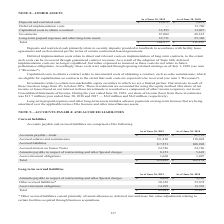According to Opentext Corporation's financial document, What are Deposits and restricted cash primarily related to? security deposits provided to landlords in accordance with facility lease agreements and cash restricted per the terms of certain contractual-based agreements. The document states: "Deposits and restricted cash primarily relate to security deposits provided to landlords in accordance with facility lease agreements and cash restric..." Also, What is the result of the adoption of Topic 606? deferred implementation costs are no longer capitalized, but rather expensed as incurred. The document states: "venues. As a result of the adoption of Topic 606, deferred implementation costs are no longer capitalized, but rather expensed as incurred as these co..." Also, What are the Fiscal years included in the table? The document shows two values: 2019 and 2018. From the document: "As of June 30, 2019 As of June 30, 2018 Deposits and restricted cash $ 13,671 $ 9,479 Deferred implementation costs — 1 As of June 30, 2019 As of June..." Also, can you calculate: What is the percentage difference of Deposits and restricted cash for June 30, 2019 vs June 30, 2018? To answer this question, I need to perform calculations using the financial data. The calculation is: (13,671-9,479)/9,479, which equals 44.22 (percentage). This is based on the information: "30, 2018 Deposits and restricted cash $ 13,671 $ 9,479 Deferred implementation costs — 13,740 Capitalized costs to obtain a contract 35,593 13,027 Investm s of June 30, 2018 Deposits and restricted ca..." The key data points involved are: 13,671, 9,479. Also, can you calculate: What is the Average annual total costs for both Fiscal years? To answer this question, I need to perform calculations using the financial data. The calculation is: (148,977+111,267)/2, which equals 130122 (in thousands). This is based on the information: "long-term assets 32,711 25,386 Total $ 148,977 $ 111,267 and other long-term assets 32,711 25,386 Total $ 148,977 $ 111,267..." The key data points involved are: 111,267, 148,977. Also, can you calculate: As of June 30, 2019, what is the Investment cost expressed as a percentage of total costs? Based on the calculation: 67,002/148,977, the result is 44.97 (percentage). This is based on the information: "ts to obtain a contract 35,593 13,027 Investments 67,002 49,635 Long-term prepaid expenses and other long-term assets 32,711 25,386 Total $ 148,977 $ 111,26 and other long-term assets 32,711 25,386 To..." The key data points involved are: 148,977, 67,002. 